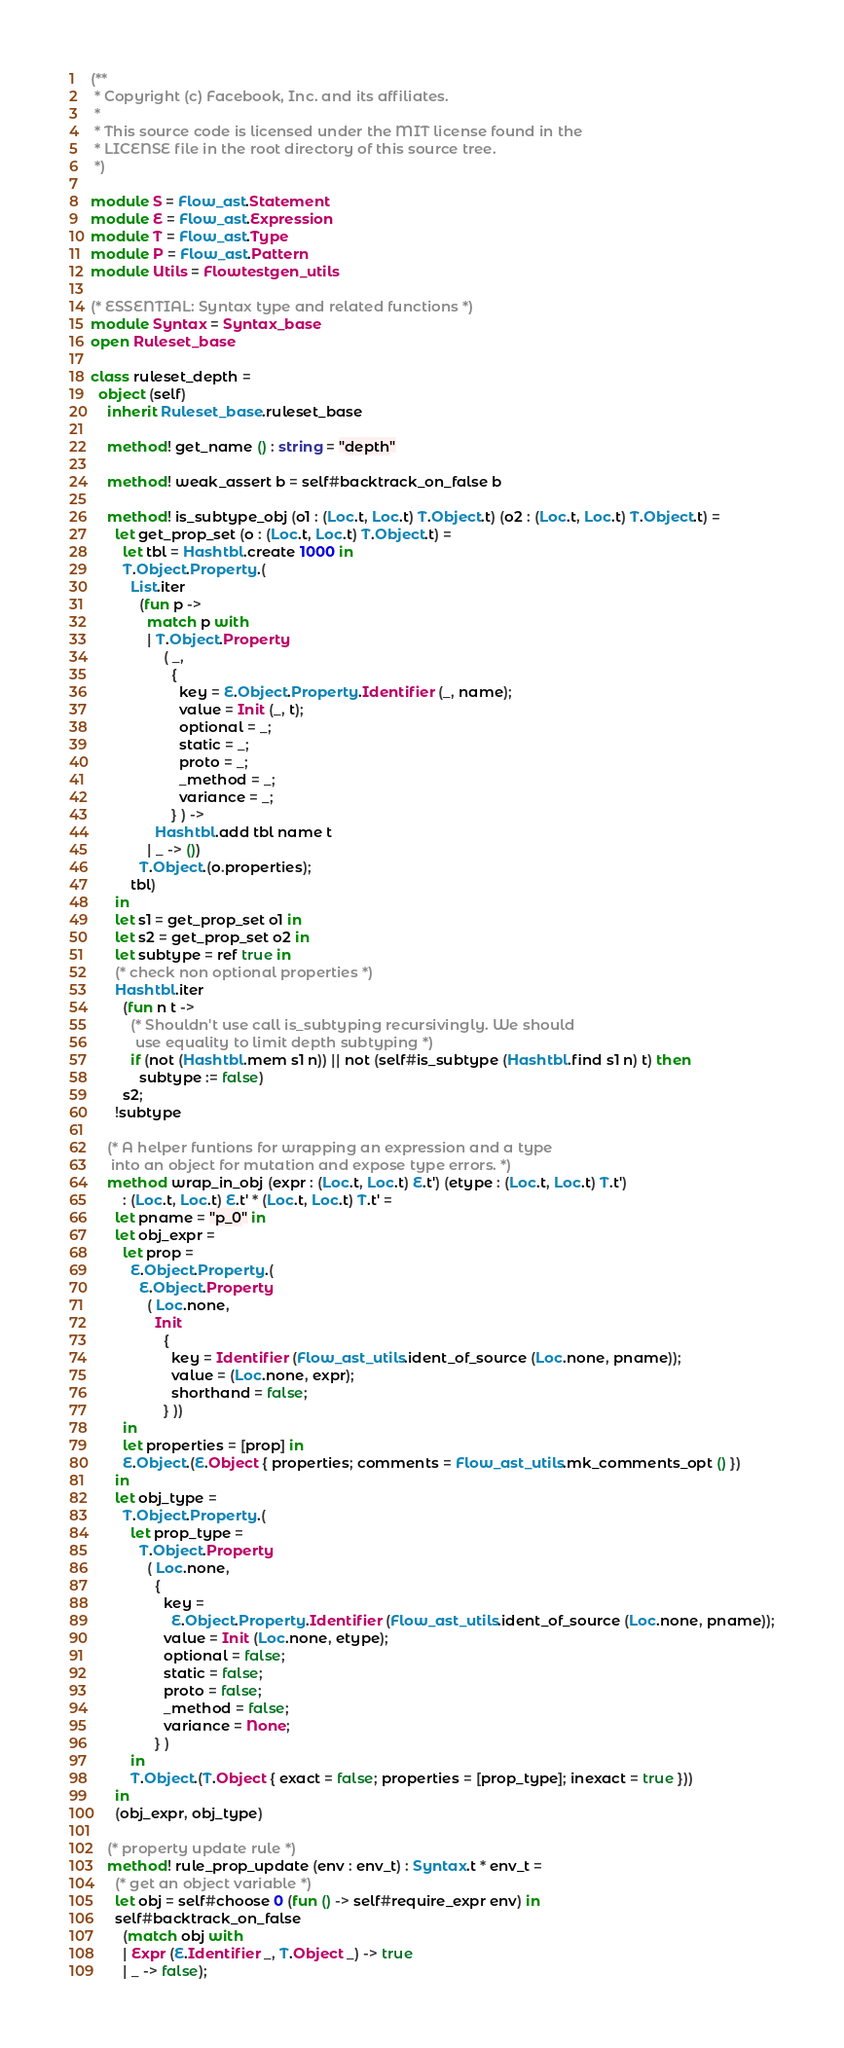Convert code to text. <code><loc_0><loc_0><loc_500><loc_500><_OCaml_>(**
 * Copyright (c) Facebook, Inc. and its affiliates.
 *
 * This source code is licensed under the MIT license found in the
 * LICENSE file in the root directory of this source tree.
 *)

module S = Flow_ast.Statement
module E = Flow_ast.Expression
module T = Flow_ast.Type
module P = Flow_ast.Pattern
module Utils = Flowtestgen_utils

(* ESSENTIAL: Syntax type and related functions *)
module Syntax = Syntax_base
open Ruleset_base

class ruleset_depth =
  object (self)
    inherit Ruleset_base.ruleset_base

    method! get_name () : string = "depth"

    method! weak_assert b = self#backtrack_on_false b

    method! is_subtype_obj (o1 : (Loc.t, Loc.t) T.Object.t) (o2 : (Loc.t, Loc.t) T.Object.t) =
      let get_prop_set (o : (Loc.t, Loc.t) T.Object.t) =
        let tbl = Hashtbl.create 1000 in
        T.Object.Property.(
          List.iter
            (fun p ->
              match p with
              | T.Object.Property
                  ( _,
                    {
                      key = E.Object.Property.Identifier (_, name);
                      value = Init (_, t);
                      optional = _;
                      static = _;
                      proto = _;
                      _method = _;
                      variance = _;
                    } ) ->
                Hashtbl.add tbl name t
              | _ -> ())
            T.Object.(o.properties);
          tbl)
      in
      let s1 = get_prop_set o1 in
      let s2 = get_prop_set o2 in
      let subtype = ref true in
      (* check non optional properties *)
      Hashtbl.iter
        (fun n t ->
          (* Shouldn't use call is_subtyping recursivingly. We should
           use equality to limit depth subtyping *)
          if (not (Hashtbl.mem s1 n)) || not (self#is_subtype (Hashtbl.find s1 n) t) then
            subtype := false)
        s2;
      !subtype

    (* A helper funtions for wrapping an expression and a type
     into an object for mutation and expose type errors. *)
    method wrap_in_obj (expr : (Loc.t, Loc.t) E.t') (etype : (Loc.t, Loc.t) T.t')
        : (Loc.t, Loc.t) E.t' * (Loc.t, Loc.t) T.t' =
      let pname = "p_0" in
      let obj_expr =
        let prop =
          E.Object.Property.(
            E.Object.Property
              ( Loc.none,
                Init
                  {
                    key = Identifier (Flow_ast_utils.ident_of_source (Loc.none, pname));
                    value = (Loc.none, expr);
                    shorthand = false;
                  } ))
        in
        let properties = [prop] in
        E.Object.(E.Object { properties; comments = Flow_ast_utils.mk_comments_opt () })
      in
      let obj_type =
        T.Object.Property.(
          let prop_type =
            T.Object.Property
              ( Loc.none,
                {
                  key =
                    E.Object.Property.Identifier (Flow_ast_utils.ident_of_source (Loc.none, pname));
                  value = Init (Loc.none, etype);
                  optional = false;
                  static = false;
                  proto = false;
                  _method = false;
                  variance = None;
                } )
          in
          T.Object.(T.Object { exact = false; properties = [prop_type]; inexact = true }))
      in
      (obj_expr, obj_type)

    (* property update rule *)
    method! rule_prop_update (env : env_t) : Syntax.t * env_t =
      (* get an object variable *)
      let obj = self#choose 0 (fun () -> self#require_expr env) in
      self#backtrack_on_false
        (match obj with
        | Expr (E.Identifier _, T.Object _) -> true
        | _ -> false);</code> 